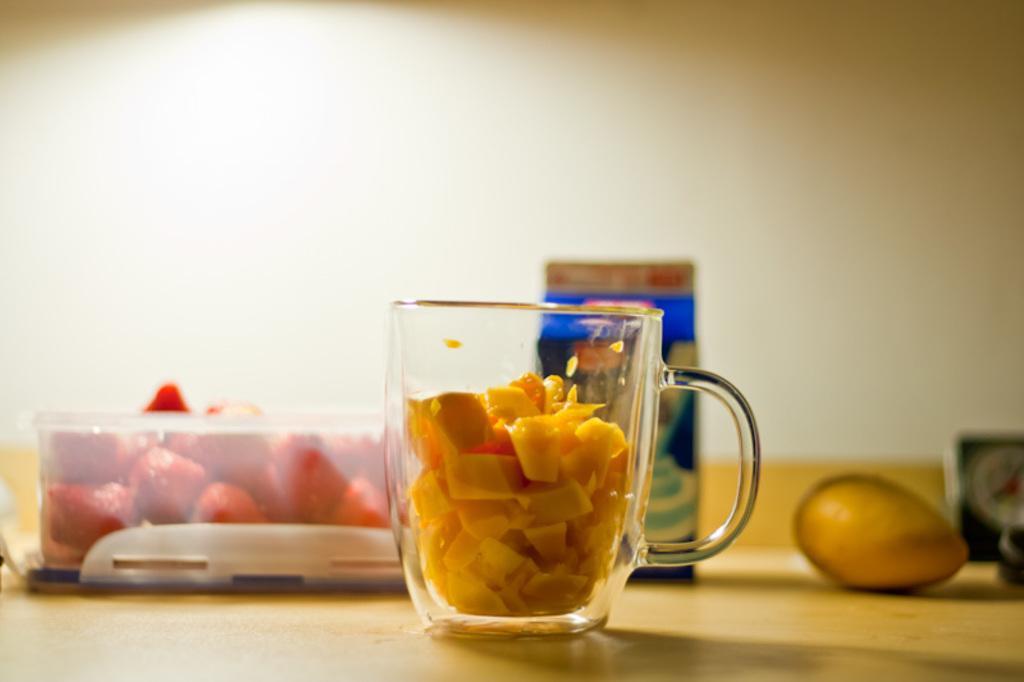In one or two sentences, can you explain what this image depicts? In this image I can see the table. On the table I can see the jug and box with fruits. To the side I can see a mango and the box. I can see the wall in the back. 